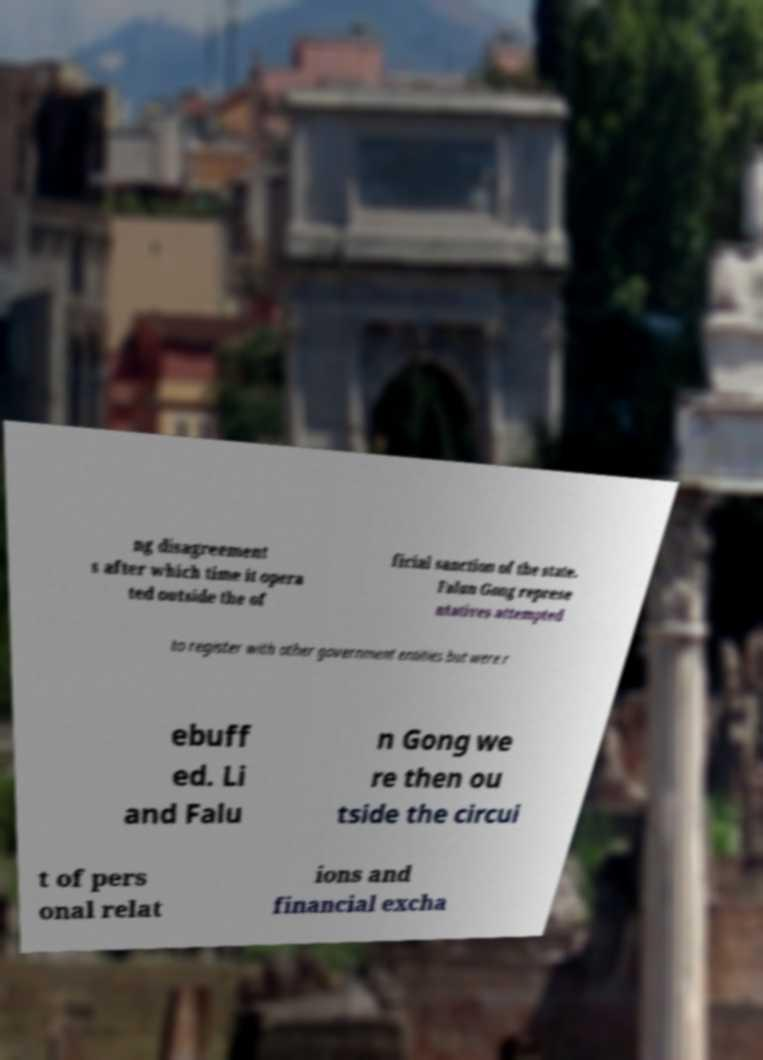Could you assist in decoding the text presented in this image and type it out clearly? ng disagreement s after which time it opera ted outside the of ficial sanction of the state. Falun Gong represe ntatives attempted to register with other government entities but were r ebuff ed. Li and Falu n Gong we re then ou tside the circui t of pers onal relat ions and financial excha 